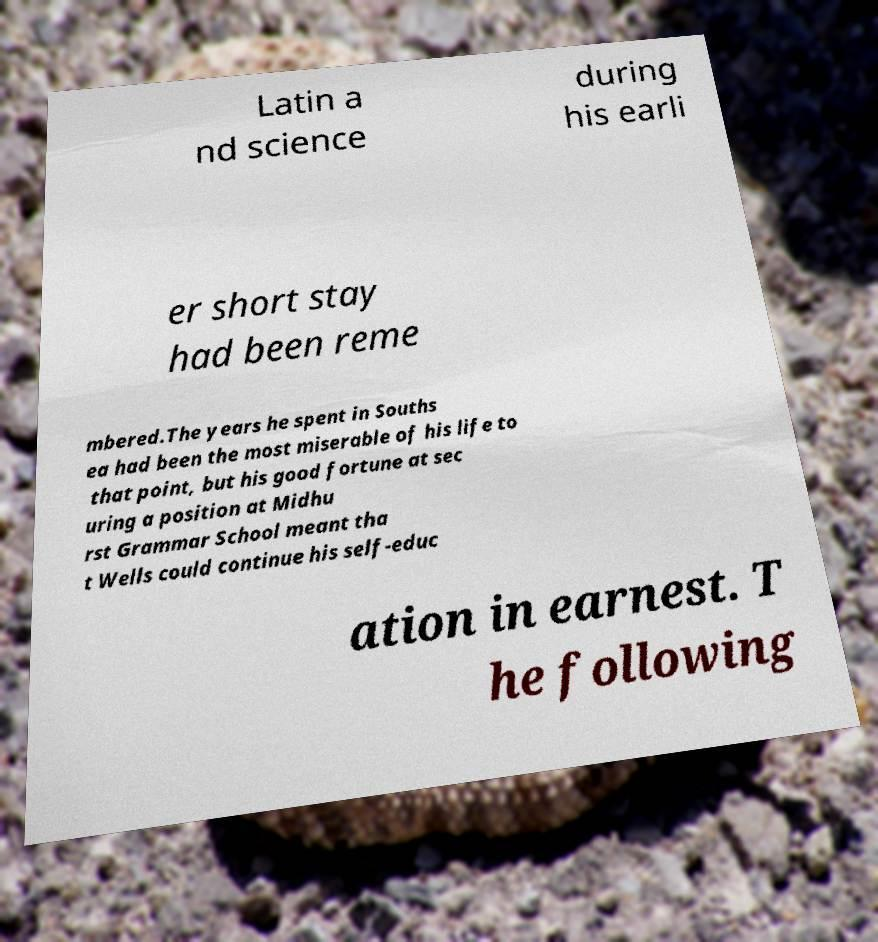I need the written content from this picture converted into text. Can you do that? Latin a nd science during his earli er short stay had been reme mbered.The years he spent in Souths ea had been the most miserable of his life to that point, but his good fortune at sec uring a position at Midhu rst Grammar School meant tha t Wells could continue his self-educ ation in earnest. T he following 